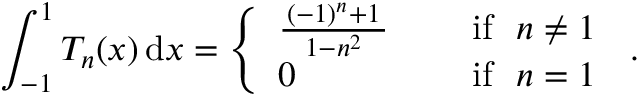<formula> <loc_0><loc_0><loc_500><loc_500>\int _ { - 1 } ^ { 1 } T _ { n } ( x ) \, d x = { \left \{ \begin{array} { l l } { { \frac { \, ( - 1 ) ^ { n } + 1 \, } { \, 1 - n ^ { 2 } \, } } \quad } & { { i f } n \neq 1 } \\ { 0 \quad } & { { i f } n = 1 } \end{array} } .</formula> 